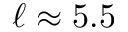<formula> <loc_0><loc_0><loc_500><loc_500>\ell \approx 5 . 5</formula> 